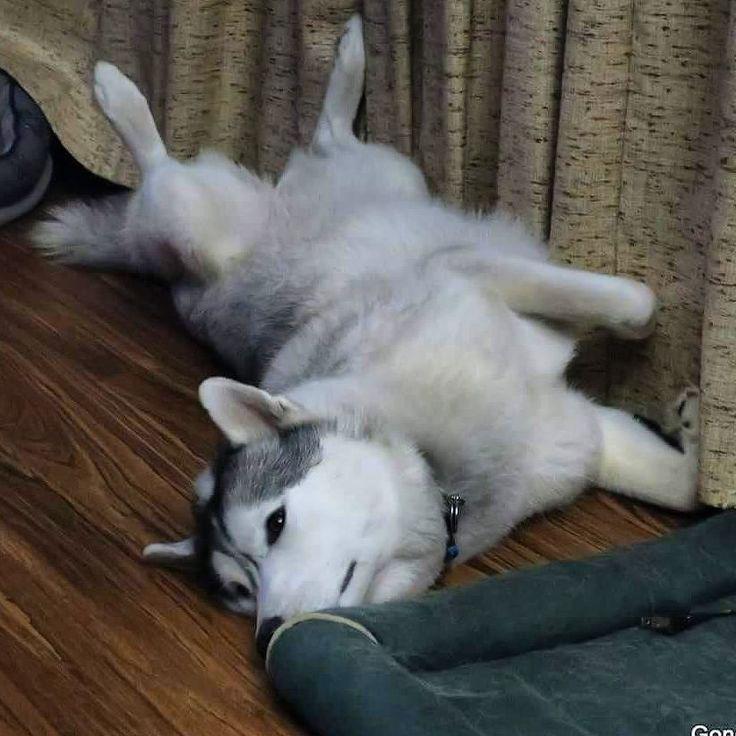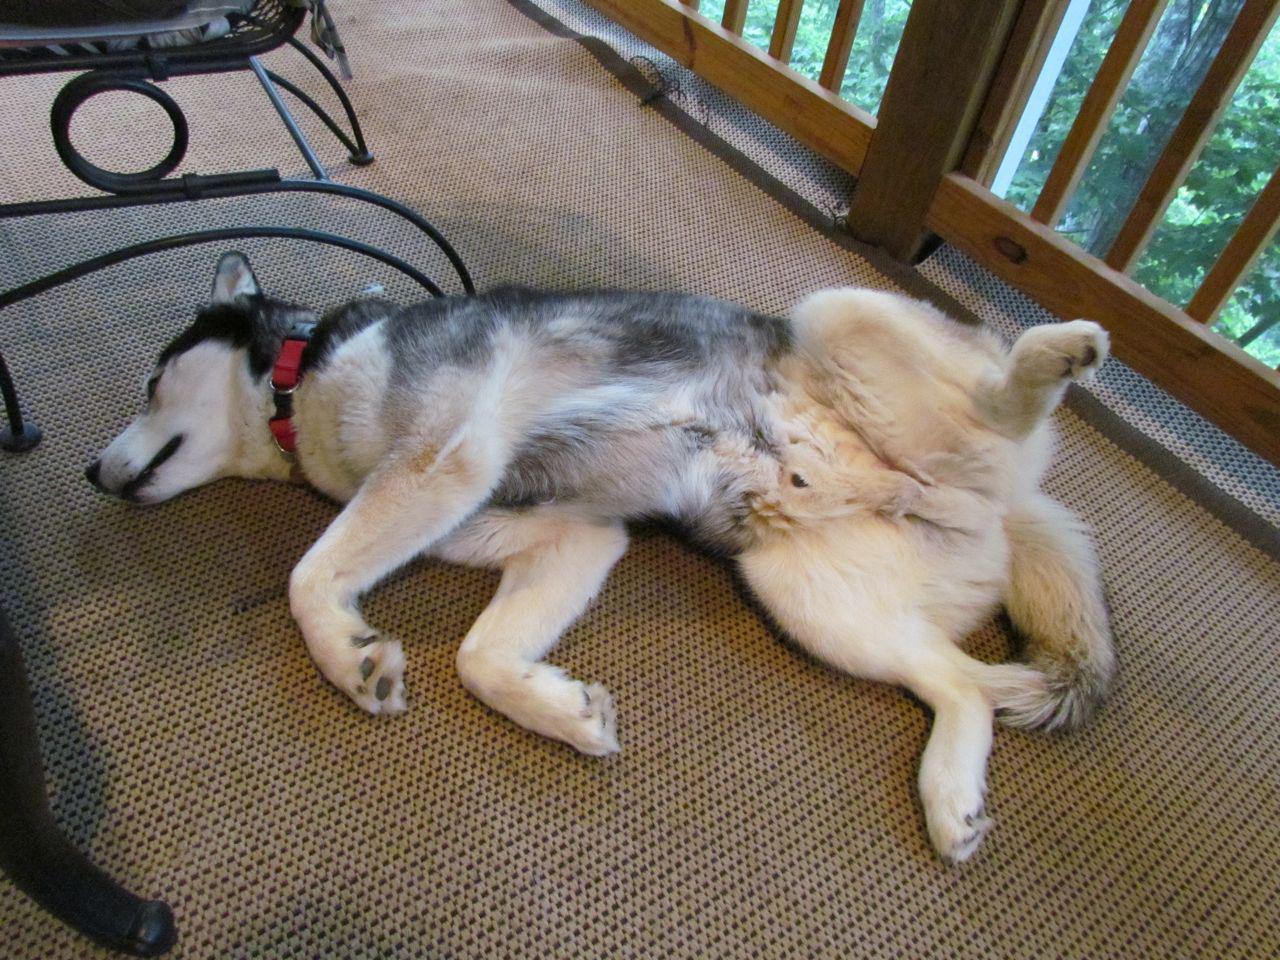The first image is the image on the left, the second image is the image on the right. Given the left and right images, does the statement "Two dogs are sitting." hold true? Answer yes or no. No. The first image is the image on the left, the second image is the image on the right. Analyze the images presented: Is the assertion "The combined images include a dog wearing a bow,  at least one dog sitting upright, at least one dog looking upward, and something red on the floor in front of a dog." valid? Answer yes or no. No. 